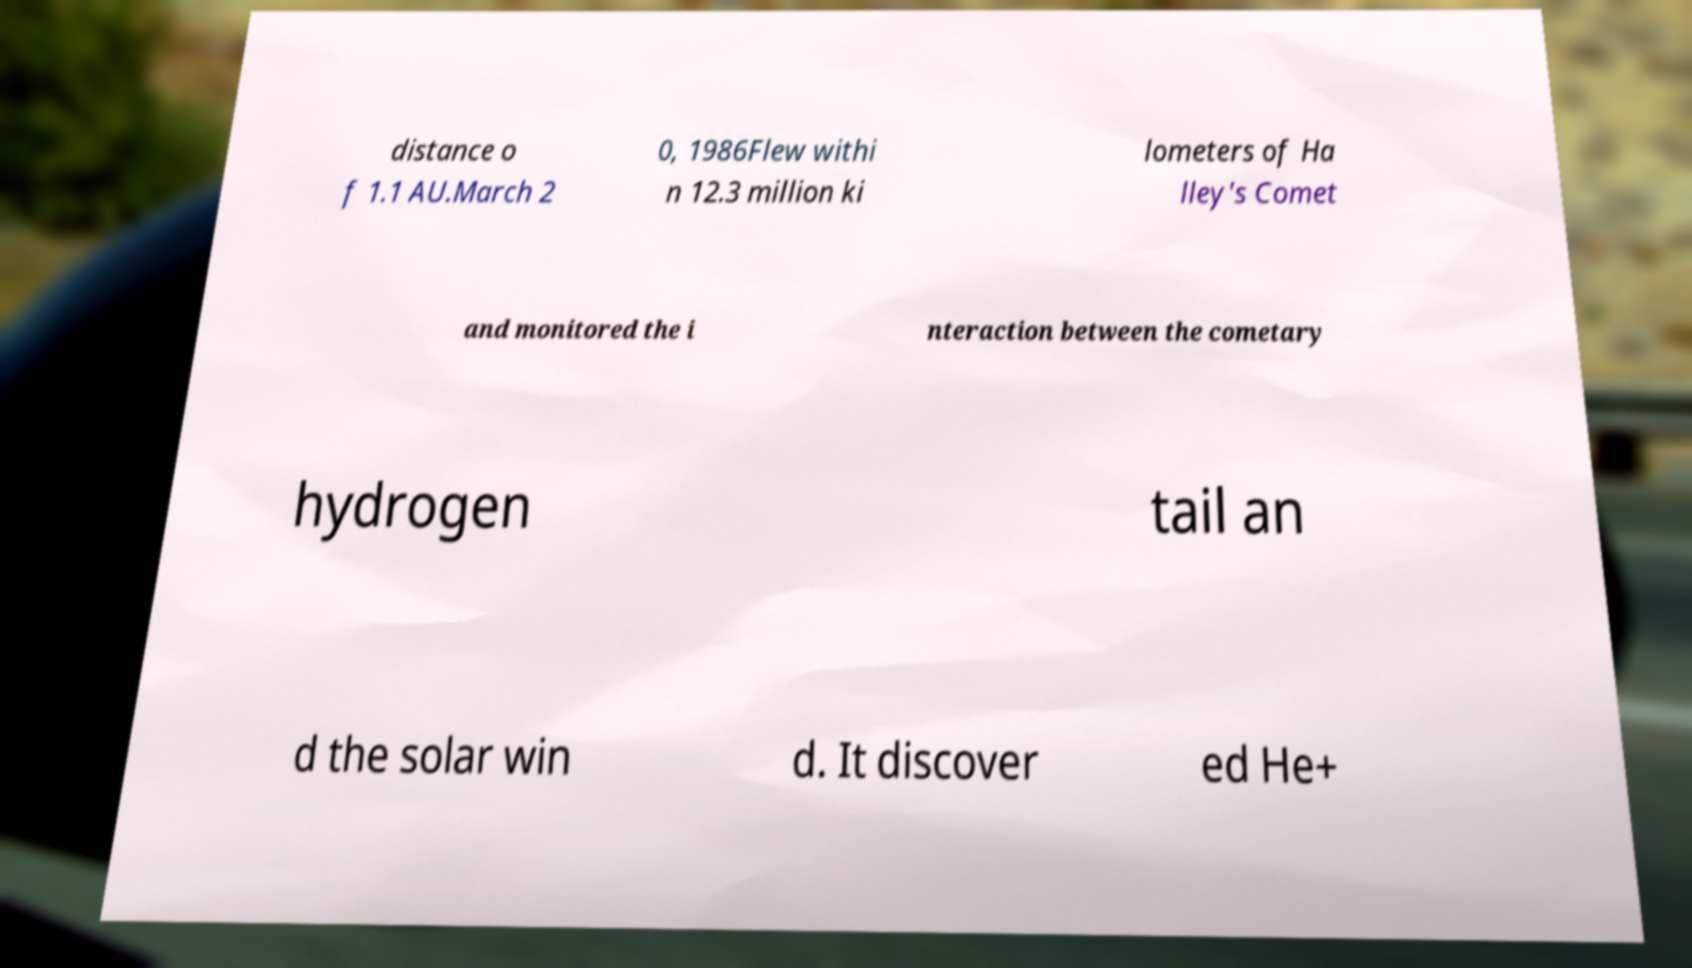Can you read and provide the text displayed in the image?This photo seems to have some interesting text. Can you extract and type it out for me? distance o f 1.1 AU.March 2 0, 1986Flew withi n 12.3 million ki lometers of Ha lley's Comet and monitored the i nteraction between the cometary hydrogen tail an d the solar win d. It discover ed He+ 